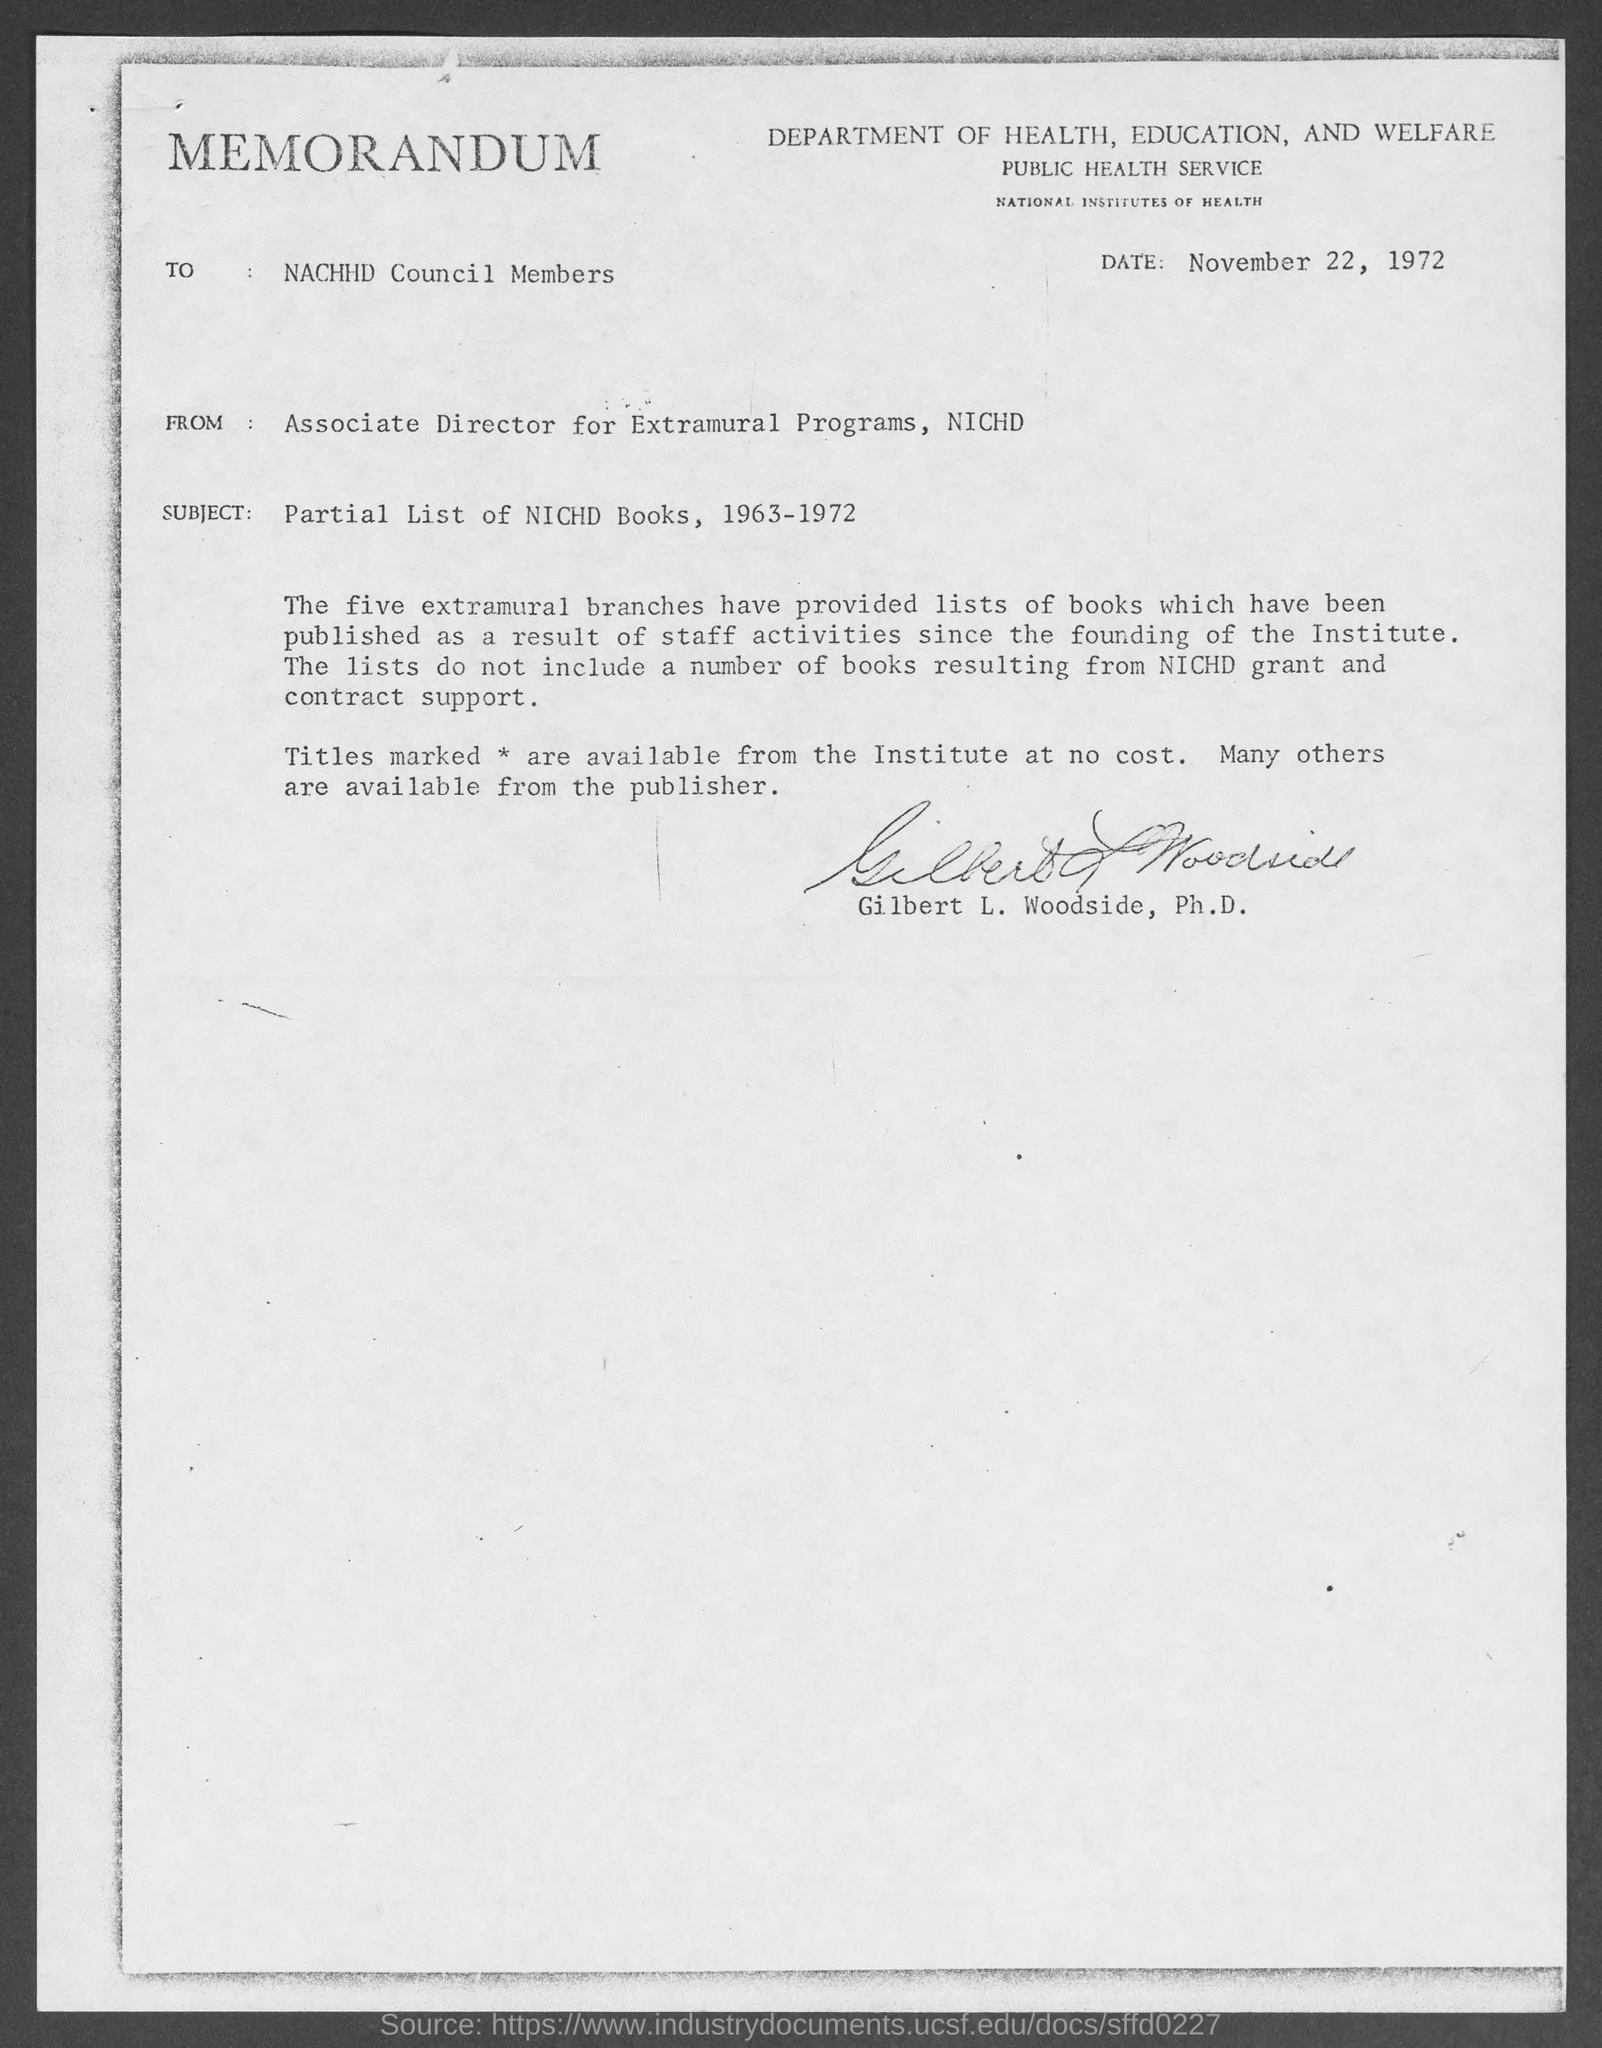When is the memorandum dated?
Provide a short and direct response. November 22, 1972. What is the position of gilbert l. woodside, ph.d?
Your answer should be compact. ASSOCIATE DIRECTOR FOR EXTRAMURAL PROGRAMS, NICHD. What is from address in memorandum ?
Provide a succinct answer. Associate Director for Extramural Programs, NICHD. What is the subject of memorandum ?
Provide a succinct answer. PARTIAL LIST OF NICHD BOOKS, 1963-1972. 